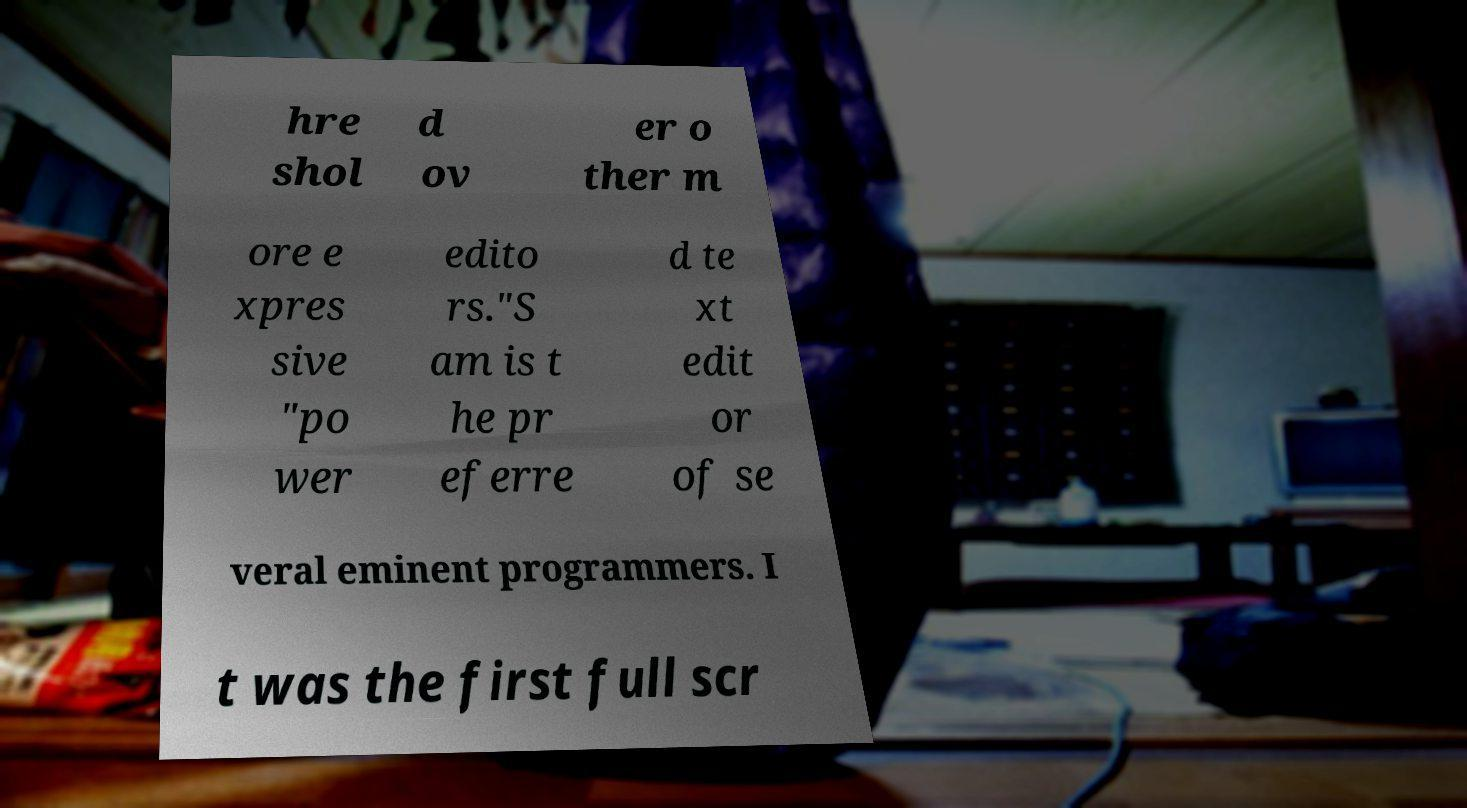I need the written content from this picture converted into text. Can you do that? hre shol d ov er o ther m ore e xpres sive "po wer edito rs."S am is t he pr eferre d te xt edit or of se veral eminent programmers. I t was the first full scr 